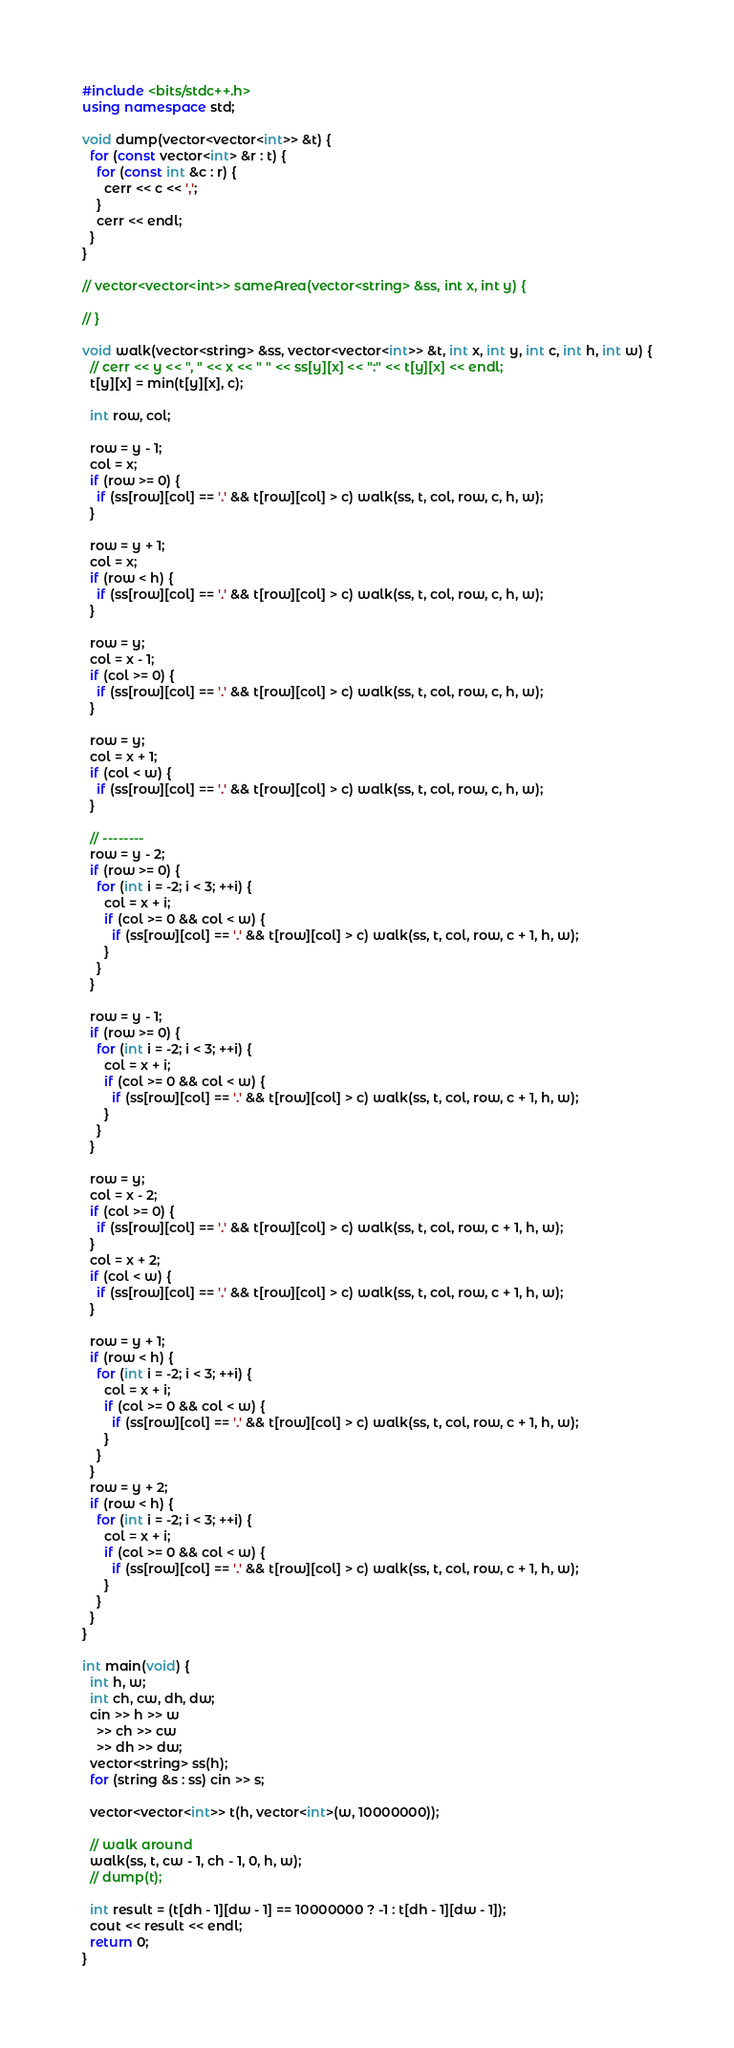<code> <loc_0><loc_0><loc_500><loc_500><_C++_>#include <bits/stdc++.h>
using namespace std;

void dump(vector<vector<int>> &t) {
  for (const vector<int> &r : t) {
    for (const int &c : r) {
      cerr << c << ',';
    }
    cerr << endl;
  }
}

// vector<vector<int>> sameArea(vector<string> &ss, int x, int y) {
  
// }

void walk(vector<string> &ss, vector<vector<int>> &t, int x, int y, int c, int h, int w) {
  // cerr << y << ", " << x << " " << ss[y][x] << ":" << t[y][x] << endl;
  t[y][x] = min(t[y][x], c);

  int row, col;

  row = y - 1;
  col = x;
  if (row >= 0) {
    if (ss[row][col] == '.' && t[row][col] > c) walk(ss, t, col, row, c, h, w);
  }

  row = y + 1;
  col = x;
  if (row < h) {
    if (ss[row][col] == '.' && t[row][col] > c) walk(ss, t, col, row, c, h, w);
  }

  row = y;
  col = x - 1;
  if (col >= 0) {
    if (ss[row][col] == '.' && t[row][col] > c) walk(ss, t, col, row, c, h, w);
  }

  row = y;
  col = x + 1;
  if (col < w) {
    if (ss[row][col] == '.' && t[row][col] > c) walk(ss, t, col, row, c, h, w);
  }

  // --------
  row = y - 2;
  if (row >= 0) {
    for (int i = -2; i < 3; ++i) {
      col = x + i;
      if (col >= 0 && col < w) {
        if (ss[row][col] == '.' && t[row][col] > c) walk(ss, t, col, row, c + 1, h, w);
      }
    }
  }

  row = y - 1;
  if (row >= 0) {
    for (int i = -2; i < 3; ++i) {
      col = x + i;
      if (col >= 0 && col < w) {
        if (ss[row][col] == '.' && t[row][col] > c) walk(ss, t, col, row, c + 1, h, w);
      }
    }
  }

  row = y;
  col = x - 2;
  if (col >= 0) {
    if (ss[row][col] == '.' && t[row][col] > c) walk(ss, t, col, row, c + 1, h, w);
  }
  col = x + 2;
  if (col < w) {
    if (ss[row][col] == '.' && t[row][col] > c) walk(ss, t, col, row, c + 1, h, w);
  }

  row = y + 1;
  if (row < h) {
    for (int i = -2; i < 3; ++i) {
      col = x + i;
      if (col >= 0 && col < w) {
        if (ss[row][col] == '.' && t[row][col] > c) walk(ss, t, col, row, c + 1, h, w);
      }
    }
  }
  row = y + 2;
  if (row < h) {
    for (int i = -2; i < 3; ++i) {
      col = x + i;
      if (col >= 0 && col < w) {
        if (ss[row][col] == '.' && t[row][col] > c) walk(ss, t, col, row, c + 1, h, w);
      }
    }
  }
}

int main(void) {
  int h, w;
  int ch, cw, dh, dw;
  cin >> h >> w
    >> ch >> cw
    >> dh >> dw;
  vector<string> ss(h);
  for (string &s : ss) cin >> s;

  vector<vector<int>> t(h, vector<int>(w, 10000000));

  // walk around
  walk(ss, t, cw - 1, ch - 1, 0, h, w);
  // dump(t);

  int result = (t[dh - 1][dw - 1] == 10000000 ? -1 : t[dh - 1][dw - 1]);
  cout << result << endl;
  return 0;
}</code> 